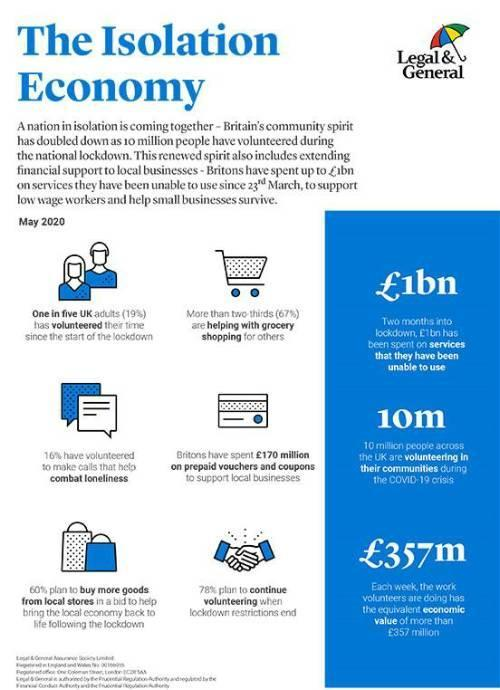spending money on vouchers and coupons was helpful for whom?
Answer the question with a short phrase. local businesses How are two-thirds of the people in UK helping others? grocery shopping what plan by the people will help revive local economy ? buy more goods from local stores In what way was volunteering to make calls helpful? combat loneliness How many people in UK are volunteering in the communities? 10 million 